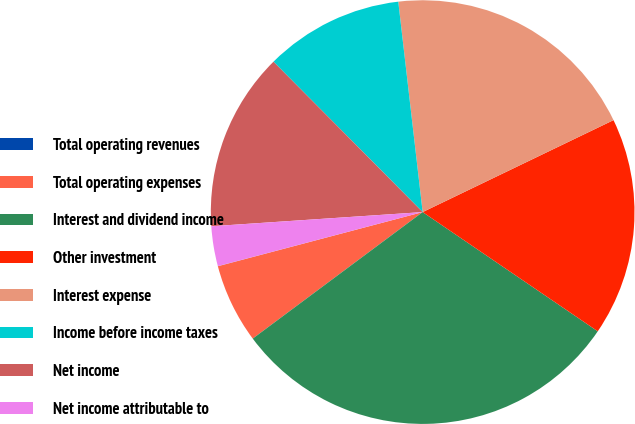Convert chart. <chart><loc_0><loc_0><loc_500><loc_500><pie_chart><fcel>Total operating revenues<fcel>Total operating expenses<fcel>Interest and dividend income<fcel>Other investment<fcel>Interest expense<fcel>Income before income taxes<fcel>Net income<fcel>Net income attributable to<nl><fcel>0.01%<fcel>6.07%<fcel>30.3%<fcel>16.66%<fcel>19.69%<fcel>10.6%<fcel>13.63%<fcel>3.04%<nl></chart> 